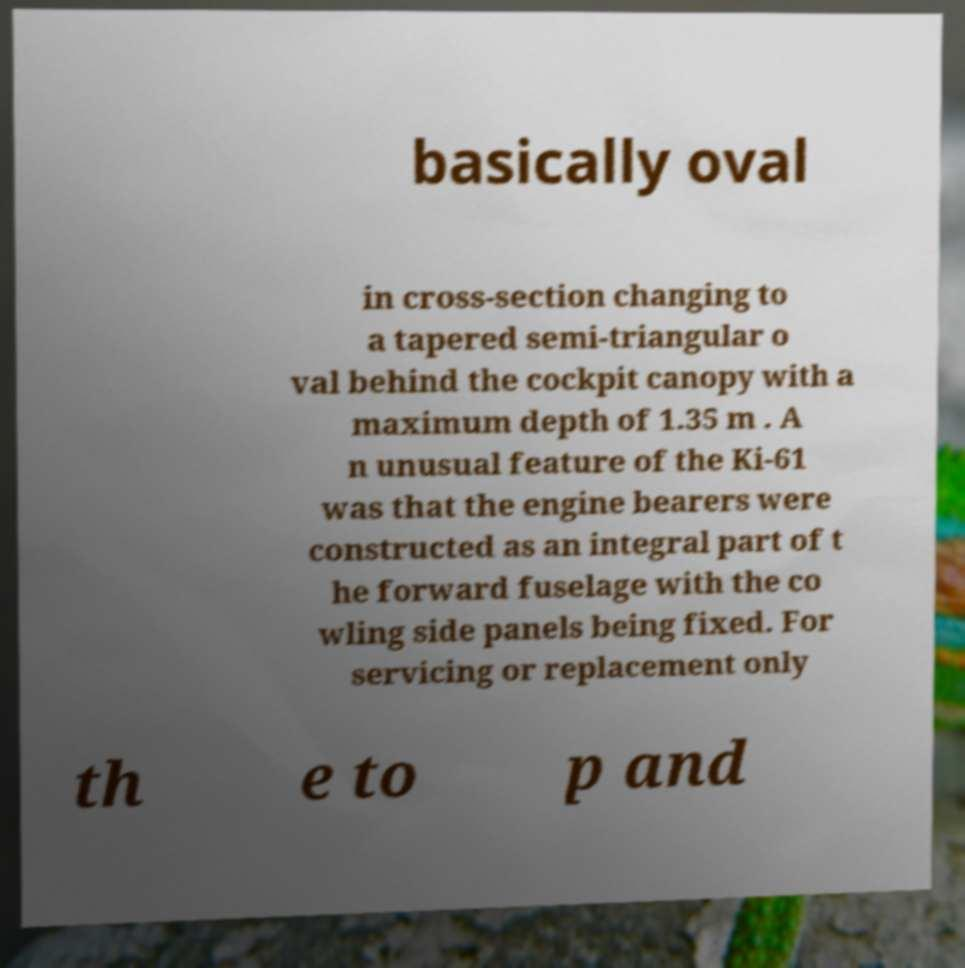Please identify and transcribe the text found in this image. basically oval in cross-section changing to a tapered semi-triangular o val behind the cockpit canopy with a maximum depth of 1.35 m . A n unusual feature of the Ki-61 was that the engine bearers were constructed as an integral part of t he forward fuselage with the co wling side panels being fixed. For servicing or replacement only th e to p and 